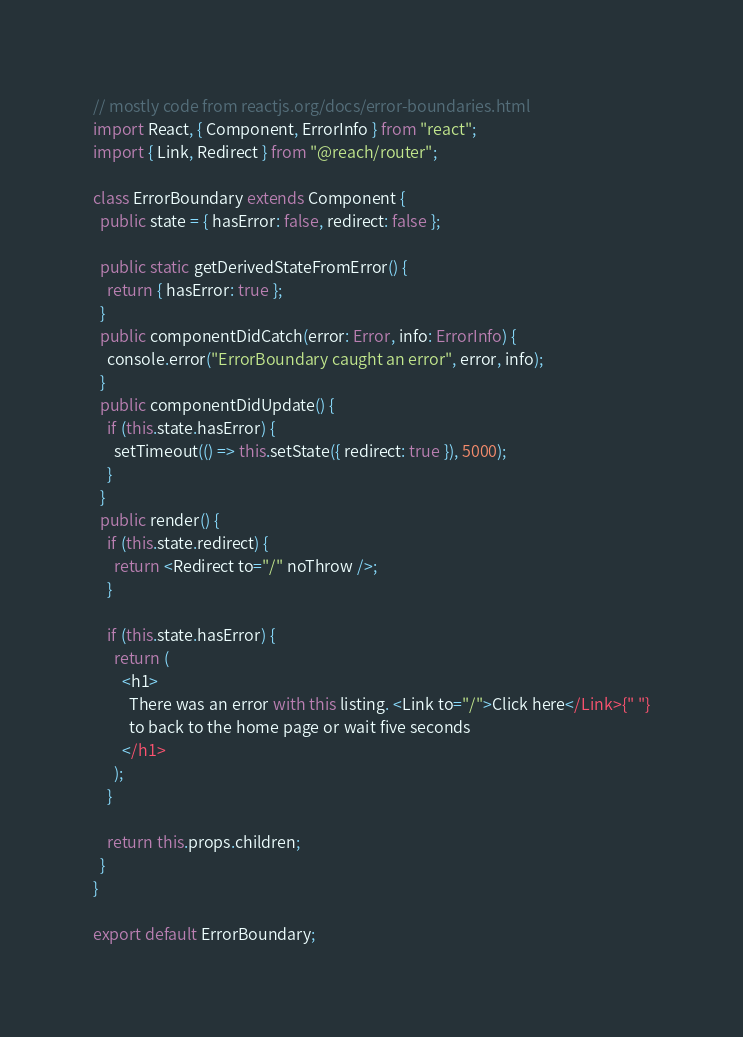Convert code to text. <code><loc_0><loc_0><loc_500><loc_500><_TypeScript_>// mostly code from reactjs.org/docs/error-boundaries.html
import React, { Component, ErrorInfo } from "react";
import { Link, Redirect } from "@reach/router";

class ErrorBoundary extends Component {
  public state = { hasError: false, redirect: false };

  public static getDerivedStateFromError() {
    return { hasError: true };
  }
  public componentDidCatch(error: Error, info: ErrorInfo) {
    console.error("ErrorBoundary caught an error", error, info);
  }
  public componentDidUpdate() {
    if (this.state.hasError) {
      setTimeout(() => this.setState({ redirect: true }), 5000);
    }
  }
  public render() {
    if (this.state.redirect) {
      return <Redirect to="/" noThrow />;
    }

    if (this.state.hasError) {
      return (
        <h1>
          There was an error with this listing. <Link to="/">Click here</Link>{" "}
          to back to the home page or wait five seconds
        </h1>
      );
    }

    return this.props.children;
  }
}

export default ErrorBoundary;
</code> 